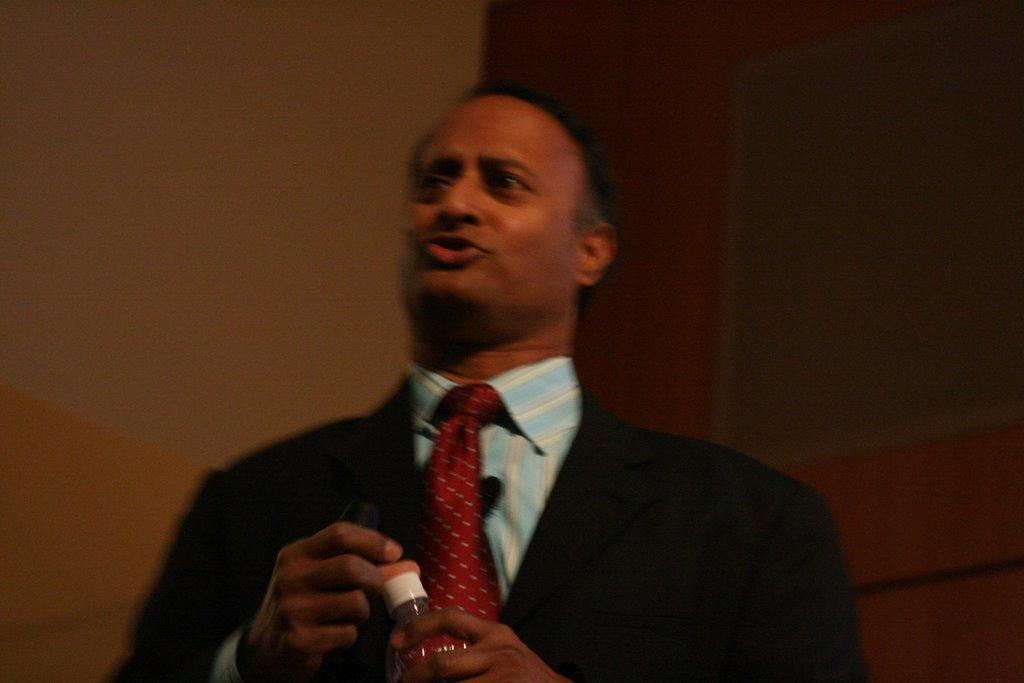What is the main subject of the image? There is a person in the image. What is the person doing in the image? The person is standing. What object is the person holding in the image? The person is holding a water bottle. What type of pest can be seen crawling on the person's shoulder in the image? There is no pest visible on the person's shoulder in the image. 